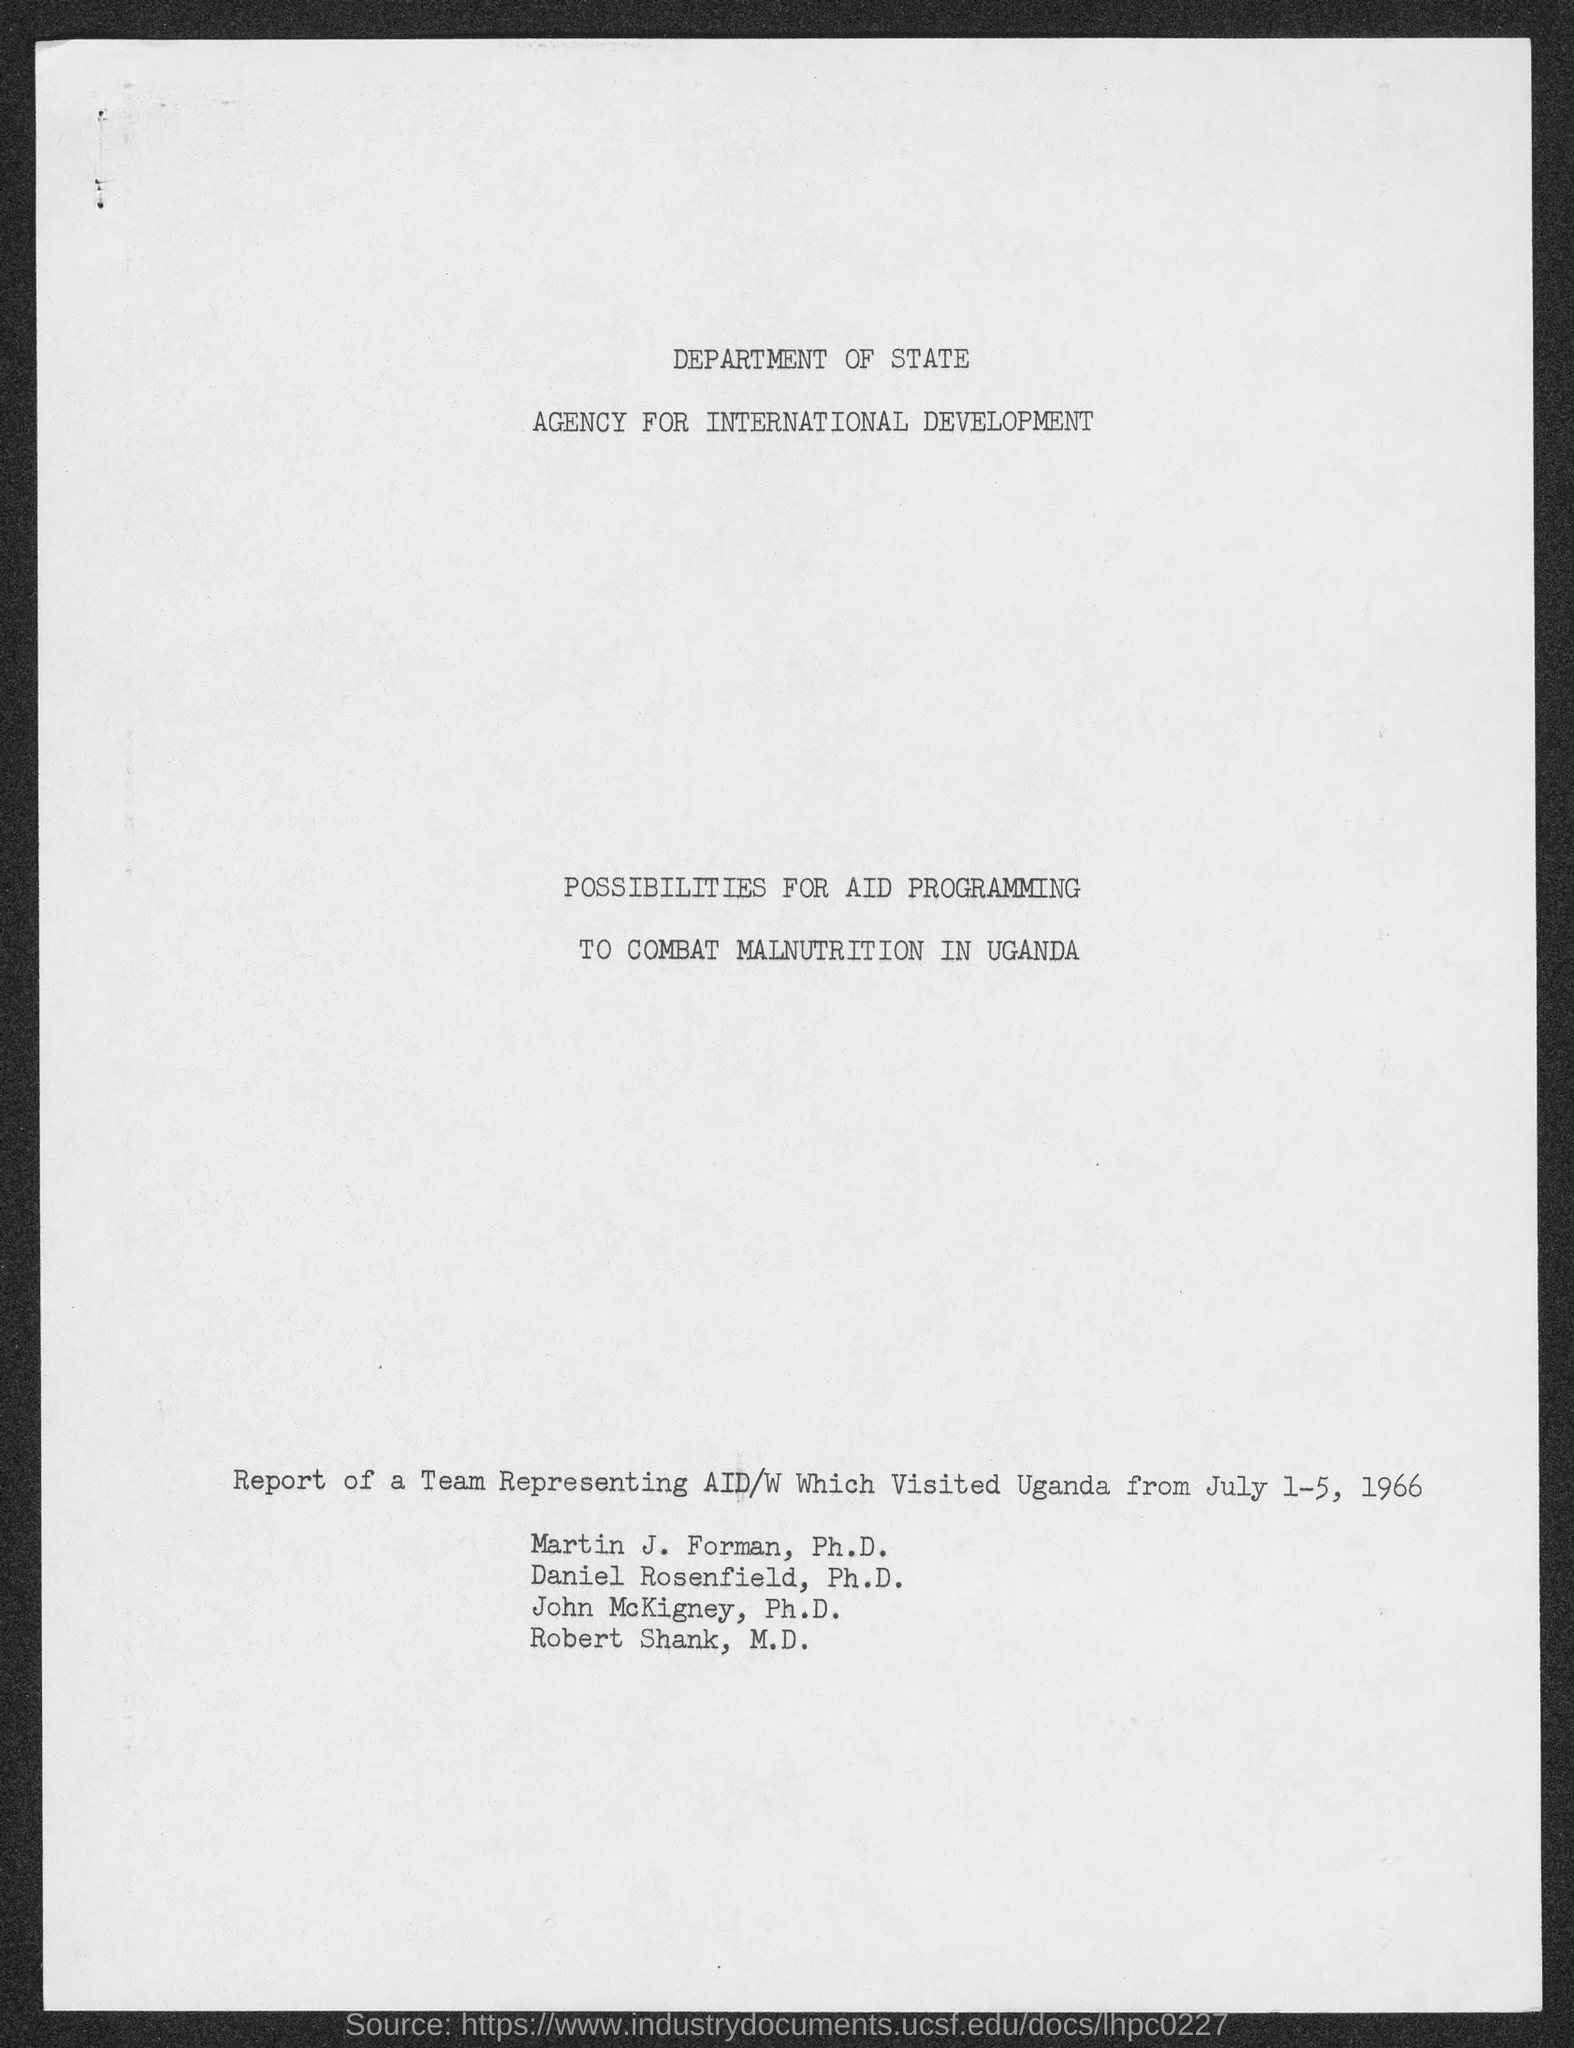Which department publish the report ?
Offer a terse response. DEPARTMENT OF STATE AGENCY FOR INTERNATIONAL DEVELOPMENT. What is the title of the report ?
Offer a very short reply. POSSIBILITIES FOR AID PROGRAMMING TO COMBAT MALNUTRITION IN UGANDA. When the team representing AID/W visited Uganda ?
Provide a succinct answer. July 1-5, 1966. What is the qualification of " Martin J. Forman " ?
Give a very brief answer. Ph.D. What is the qualification of " John McKigney " ?
Make the answer very short. Ph.D. What is the qualification of " Robert Shank " ?
Ensure brevity in your answer.  M.D. 